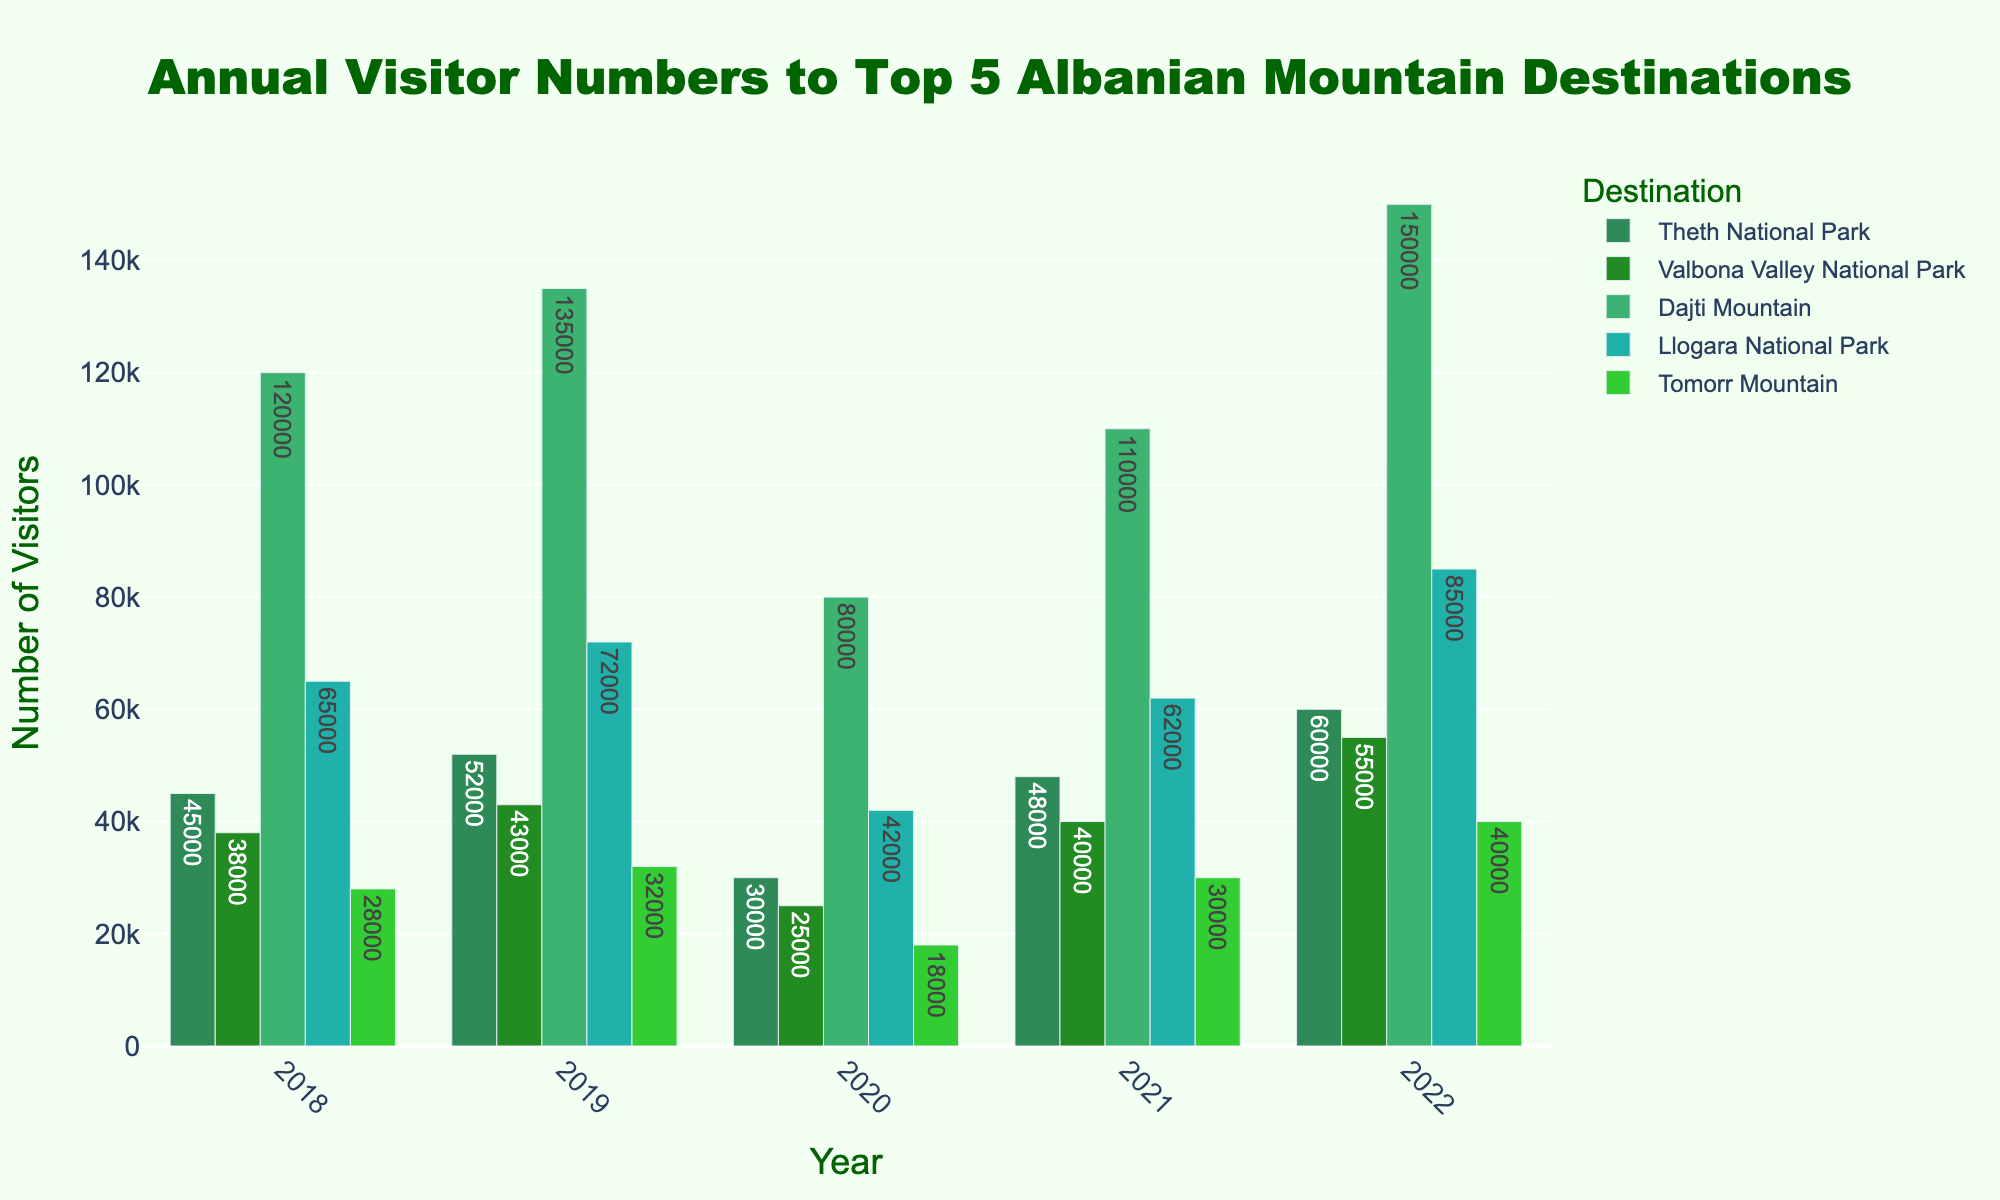Which destination had the highest number of visitors in 2022? To find the destination with the highest number of visitors in 2022, look at the height of the bars for each destination in that year. Dajti Mountain has the tallest bar in 2022.
Answer: Dajti Mountain What is the total number of visitors to Theth National Park over the five years? Add the visitor numbers for Theth National Park for the years 2018, 2019, 2020, 2021, and 2022: 45000 + 52000 + 30000 + 48000 + 60000 = 235000.
Answer: 235000 How did the number of visitors to Valbona Valley National Park change from 2020 to 2021? Subtract the number of visitors in 2020 from the number in 2021 for Valbona Valley National Park: 40000 - 25000 = 15000.
Answer: Increased by 15000 Which year had the lowest overall visitors for Dajti Mountain? Look at the height of the bars for Dajti Mountain across all years. The shortest bar is in 2020.
Answer: 2020 Compare the visitor numbers of Theth National Park and Llogara National Park in 2021. Which had more visitors and by how much? Find the visitor numbers in 2021 for both parks and subtract the smaller from the larger. Llogara National Park had 62000 visitors, and Theth National Park had 48000 visitors: 62000 - 48000 = 14000.
Answer: Llogara National Park by 14000 What is the average number of visitors to Tomorr Mountain over the five years? Add the visitor numbers for Tomorr Mountain across all years and divide by 5: (28000 + 32000 + 18000 + 30000 + 40000) / 5 = 29600.
Answer: 29600 In which year did Llogara National Park have its peak visitor count? Look at the highest bar for Llogara National Park. The tallest bar is in 2022.
Answer: 2022 Which destination saw the largest increase in visitors from 2021 to 2022? Calculate the increase for each destination from 2021 to 2022 and identify the largest. For example, Theth National Park increased by 60000 - 48000 = 12000, etc. Dajti Mountain had the largest increase with 40000.
Answer: Dajti Mountain How did the visitor numbers to Theth National Park change from 2018 to 2019? Subtract the number of visitors in 2018 from the number in 2019 for Theth National Park: 52000 - 45000 = 7000.
Answer: Increased by 7000 Among all destinations, which one had the most fluctuating visitor counts over the years? Identify the destination with the largest range by finding the difference between the maximum and minimum values over the years. For Tomorr Mountain: max is 40000, min is 18000, range is 22000. This range can be compared with other destinations.
Answer: Tomorr Mountain 